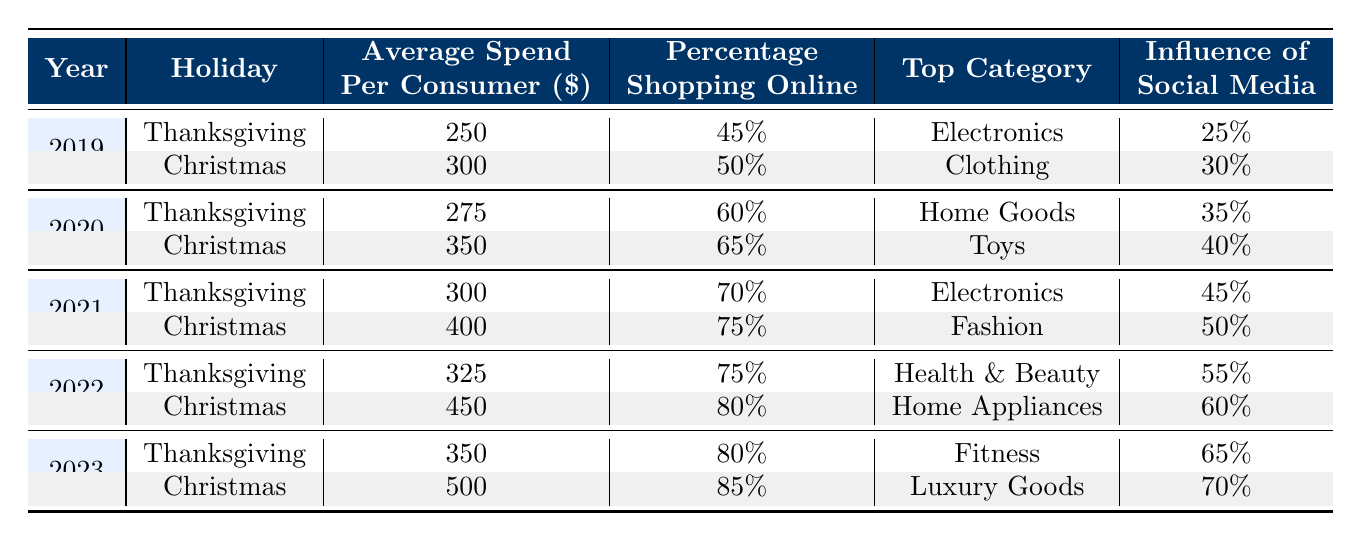What was the top category for Christmas in 2021? According to the table, the top category for Christmas in 2021 is Fashion. We can find this by locating the row for Christmas under the year 2021, where "Fashion" is listed in the Top Category column.
Answer: Fashion How much did consumers spend on average per person during Thanksgiving in 2020? The average spend per consumer during Thanksgiving in 2020 is found by looking at the corresponding row for that holiday and year, which states $275.
Answer: 275 What is the percentage of consumers shopping online for Christmas in 2022 compared to Christmas in 2021? For Christmas in 2022, the percentage shopping online is 80%, while for Christmas in 2021, it is 75%. The difference is calculated as 80% - 75% = 5%.
Answer: 5% Was the average spend per consumer during Thanksgiving in 2019 lower than that in 2023? The average spend for Thanksgiving 2019 is $250, while for 2023 it is $350. Since $250 is less than $350, the statement is true.
Answer: Yes What was the influence of social media on shopping during Christmas in 2023? Referring to the table, the influence of social media on shopping for Christmas in 2023 is 70%. This is located in the respective row for that holiday and year.
Answer: 70 What is the increase in average spend per consumer from Thanksgiving 2021 to Thanksgiving 2023? The average spend per consumer for Thanksgiving 2021 is $300 and for Thanksgiving 2023 it is $350. The increase is calculated as $350 - $300 = $50.
Answer: 50 Which holiday in 2020 had the highest percentage of online shopping? Both Thanksgiving and Christmas in 2020 had 60% and 65% respectively. The highest percentage is found for Christmas.
Answer: Christmas Did the average spend per consumer during Thanksgiving increase or decrease from 2020 to 2021? In Thanksgiving 2020, the average spend was $275, and in 2021 it was $300. Since $300 is more than $275, the average spend increased.
Answer: Increased What was the trend in the percentage of online shopping from 2019 to 2022? Looking at the percentages, it went from 45% in 2019 to 60% in 2020, then to 70% in 2021, and finally to 75% in 2022, indicating a consistent upward trend throughout these years.
Answer: Upward trend 